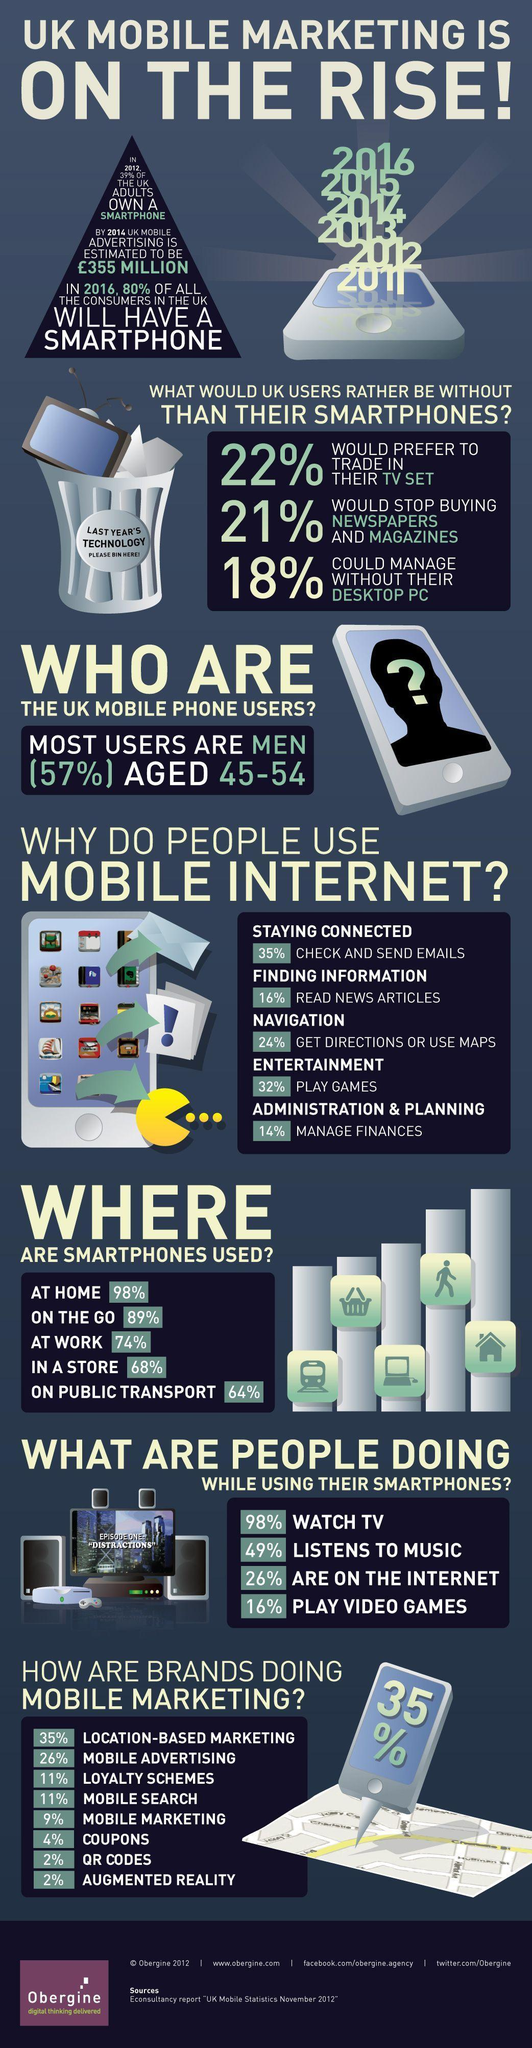What is the second most popular use for mobile internet?
Answer the question with a short phrase. play games How many people play video games while using the smartphones? 16% What is the least most popular use for mobile internet? manage finances What do most people use mobile internet for? check and send emails where is the smartphone used most other than at home? on the go What is the second most used method by brands for mobile marketing? mobile advertising 